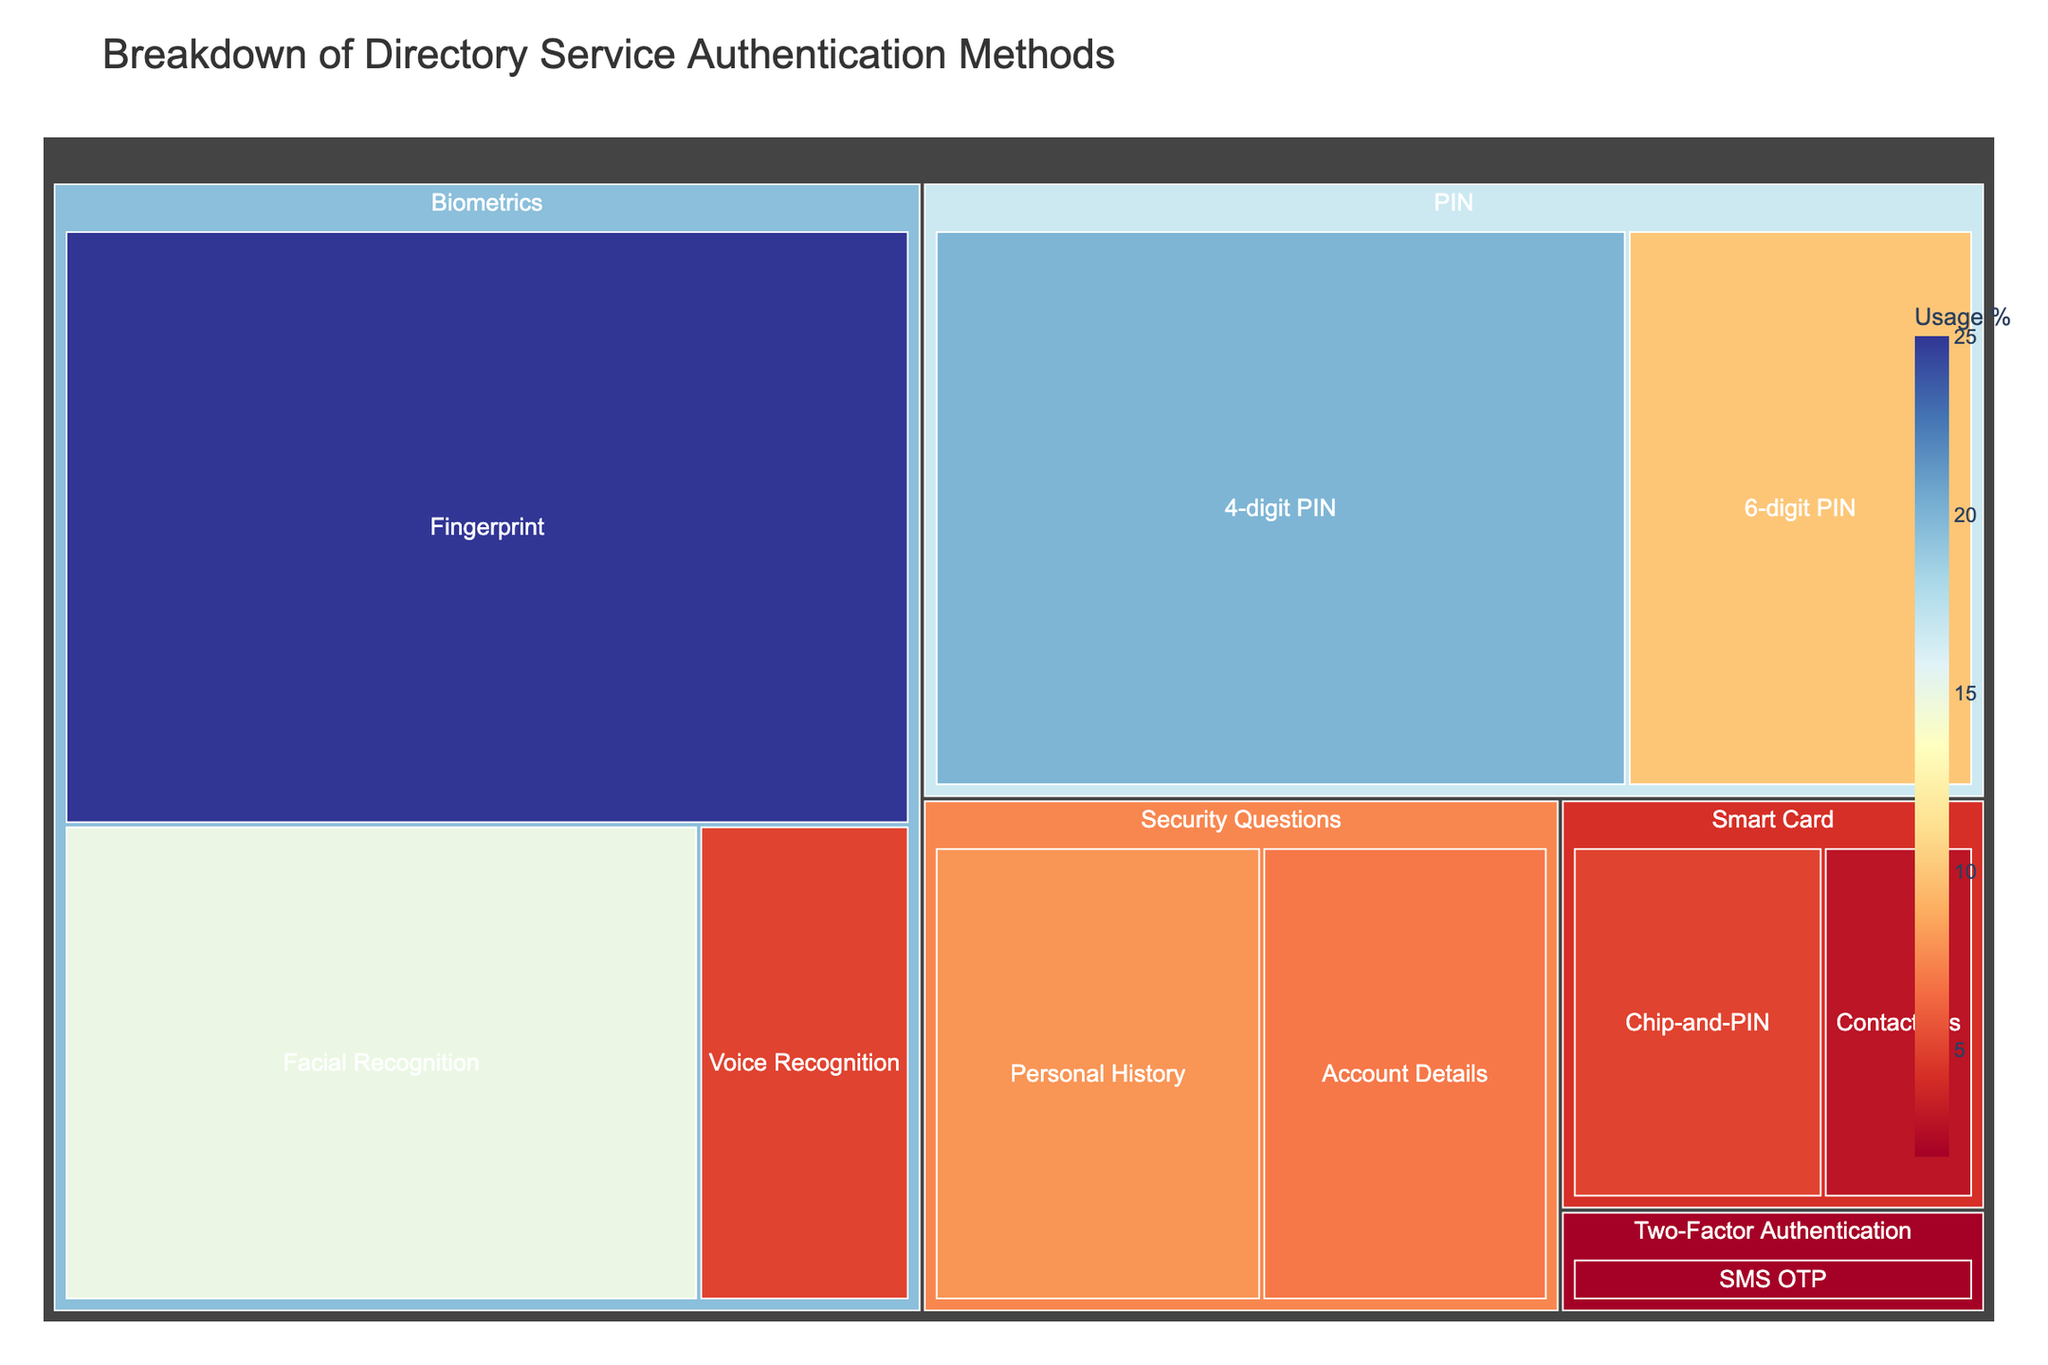What is the title of the figure? The title is shown at the top of the treemap.
Answer: Breakdown of Directory Service Authentication Methods Which authentication method has the highest usage percentage? Look at the largest section of the treemap. The section "Biometrics" with combined types of fingerprint, facial recognition, voice recognition has a total of 45% usage.
Answer: Biometrics What is the usage percentage of the 4-digit PIN? Refer to the section labeled "4-digit PIN" within the "PIN" category in the treemap.
Answer: 20% Which smart card type has higher usage, Chip-and-PIN or Contactless? Compare the sizes of the "Chip-and-PIN" and "Contactless" sections in the smart card category.
Answer: Chip-and-PIN How much higher is the usage percentage of Fingerprint compared to Voice Recognition? Subtract the percentage of Voice Recognition from Fingerprint.
Answer: 20% What's the total usage percentage for the Security Questions category? Add the usage percentages of "Personal History" and "Account Details".
Answer: 15% Which method has lower usage: SMS OTP or Contactless Smart Card? Look at the SMS OTP and Contactless sections and compare their sizes.
Answer: SMS OTP What is the average usage percentage of the biometrics methods? Add the usage percentages of Fingerprint (25), Facial Recognition (15), and Voice Recognition (5), then divide by the number of methods (3).
Answer: 15% Within the Biometrics category, which type has the second highest usage percentage? Identify the second largest section within the Biometrics category.
Answer: Facial Recognition How do the total usage percentages of PIN and Security Questions compare? Add the percentages for all types within the PIN category and the Security Questions category, then compare the sums.
Answer: PIN category has higher usage 